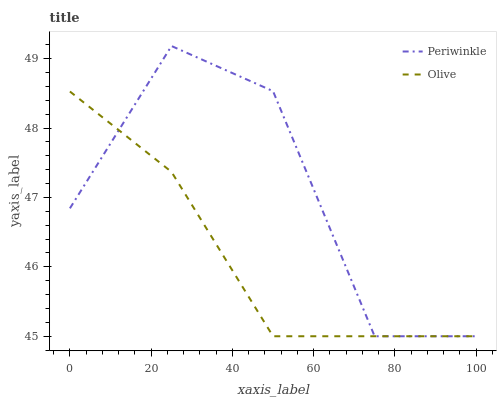Does Periwinkle have the minimum area under the curve?
Answer yes or no. No. Is Periwinkle the smoothest?
Answer yes or no. No. 